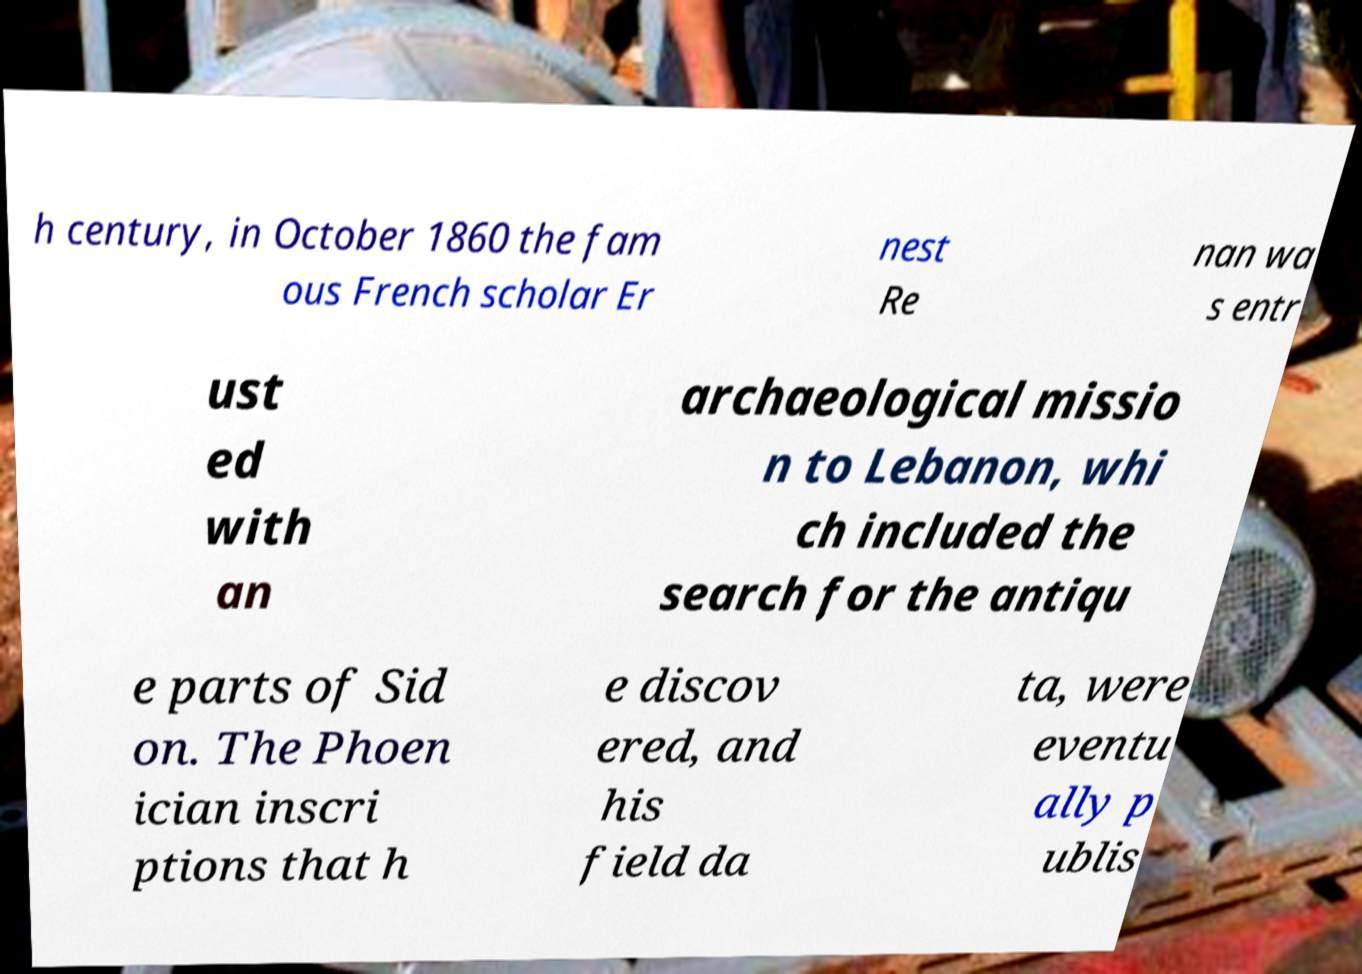Can you accurately transcribe the text from the provided image for me? h century, in October 1860 the fam ous French scholar Er nest Re nan wa s entr ust ed with an archaeological missio n to Lebanon, whi ch included the search for the antiqu e parts of Sid on. The Phoen ician inscri ptions that h e discov ered, and his field da ta, were eventu ally p ublis 